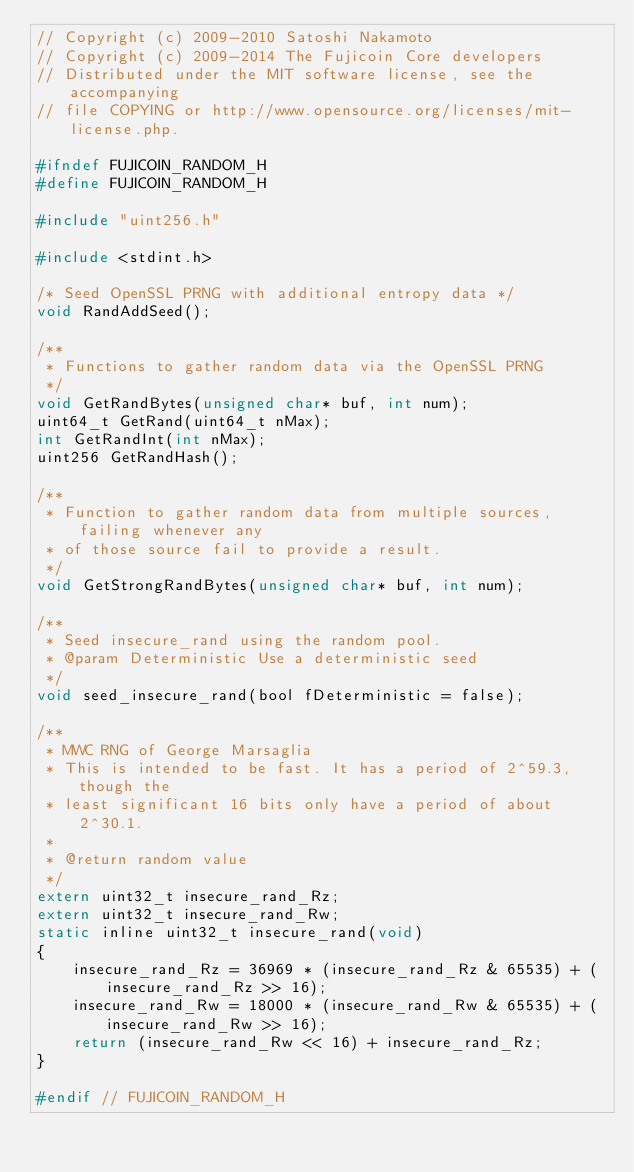<code> <loc_0><loc_0><loc_500><loc_500><_C_>// Copyright (c) 2009-2010 Satoshi Nakamoto
// Copyright (c) 2009-2014 The Fujicoin Core developers
// Distributed under the MIT software license, see the accompanying
// file COPYING or http://www.opensource.org/licenses/mit-license.php.

#ifndef FUJICOIN_RANDOM_H
#define FUJICOIN_RANDOM_H

#include "uint256.h"

#include <stdint.h>

/* Seed OpenSSL PRNG with additional entropy data */
void RandAddSeed();

/**
 * Functions to gather random data via the OpenSSL PRNG
 */
void GetRandBytes(unsigned char* buf, int num);
uint64_t GetRand(uint64_t nMax);
int GetRandInt(int nMax);
uint256 GetRandHash();

/**
 * Function to gather random data from multiple sources, failing whenever any
 * of those source fail to provide a result.
 */
void GetStrongRandBytes(unsigned char* buf, int num);

/**
 * Seed insecure_rand using the random pool.
 * @param Deterministic Use a deterministic seed
 */
void seed_insecure_rand(bool fDeterministic = false);

/**
 * MWC RNG of George Marsaglia
 * This is intended to be fast. It has a period of 2^59.3, though the
 * least significant 16 bits only have a period of about 2^30.1.
 *
 * @return random value
 */
extern uint32_t insecure_rand_Rz;
extern uint32_t insecure_rand_Rw;
static inline uint32_t insecure_rand(void)
{
    insecure_rand_Rz = 36969 * (insecure_rand_Rz & 65535) + (insecure_rand_Rz >> 16);
    insecure_rand_Rw = 18000 * (insecure_rand_Rw & 65535) + (insecure_rand_Rw >> 16);
    return (insecure_rand_Rw << 16) + insecure_rand_Rz;
}

#endif // FUJICOIN_RANDOM_H
</code> 